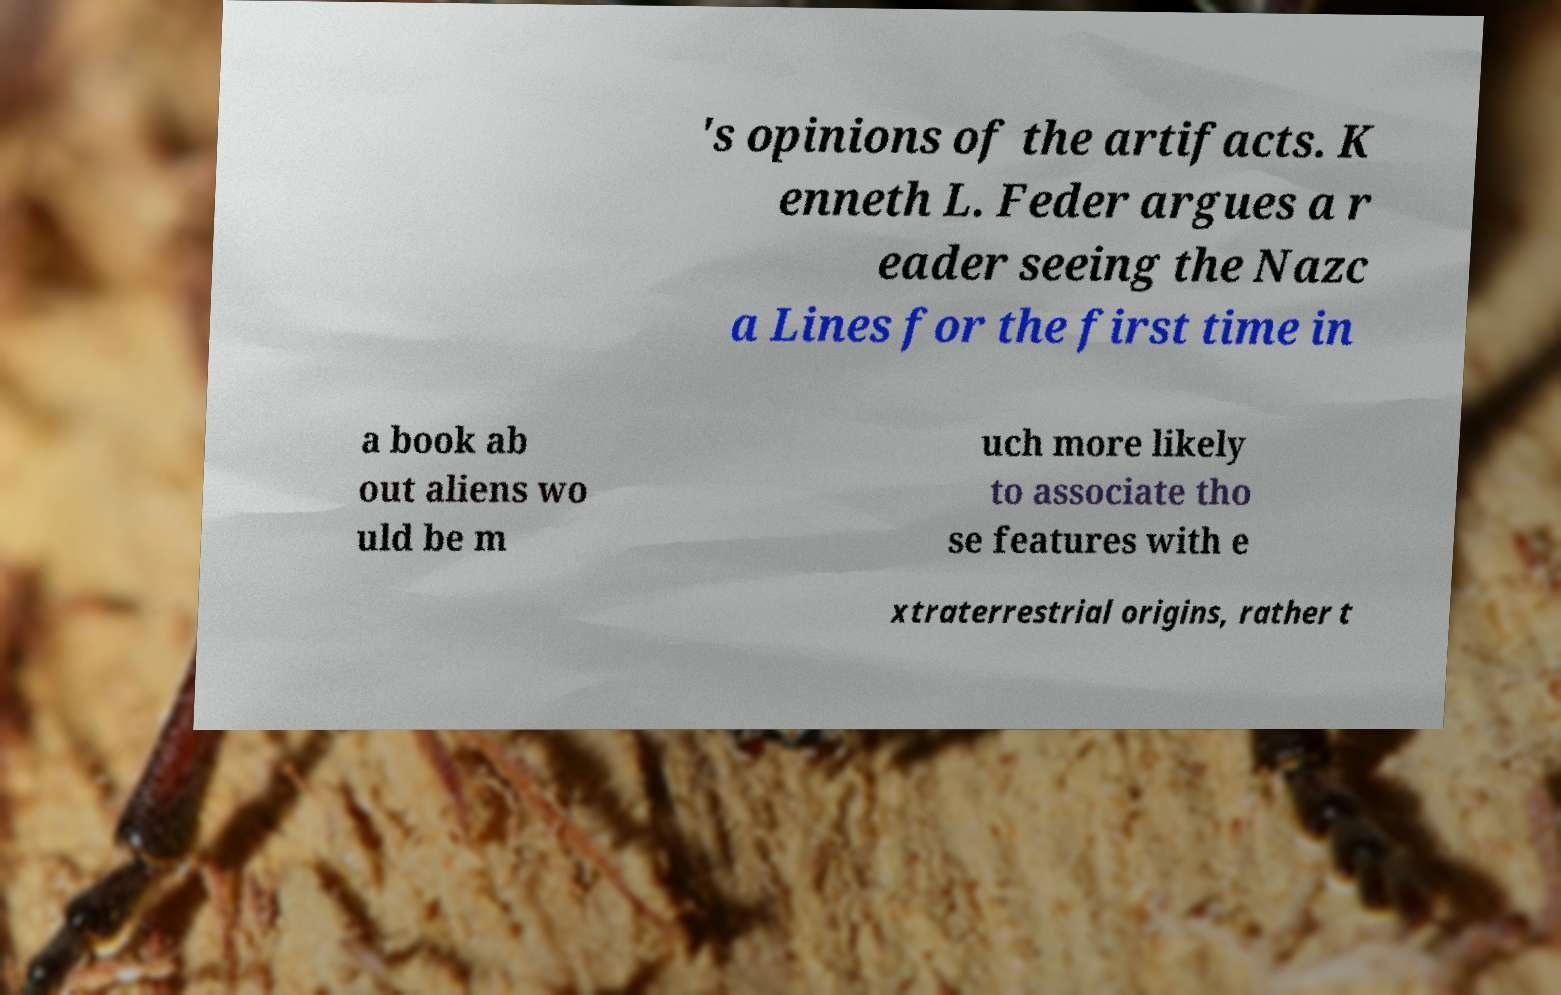Please identify and transcribe the text found in this image. 's opinions of the artifacts. K enneth L. Feder argues a r eader seeing the Nazc a Lines for the first time in a book ab out aliens wo uld be m uch more likely to associate tho se features with e xtraterrestrial origins, rather t 